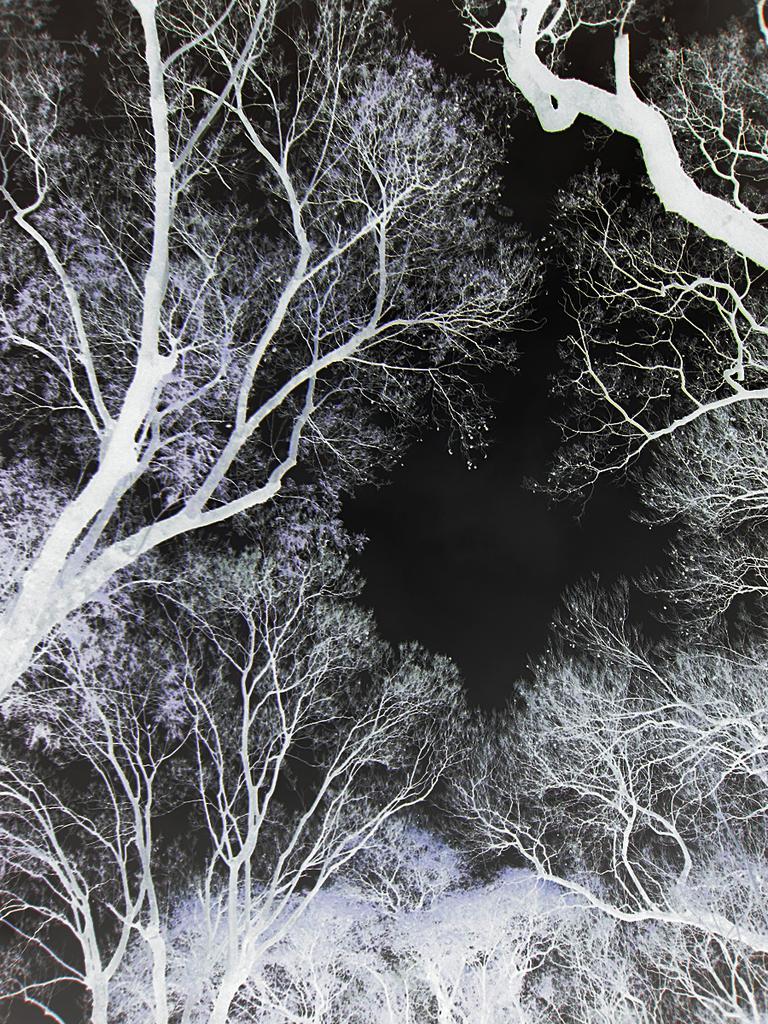In one or two sentences, can you explain what this image depicts? In this image I can see there are trees in the middle it is a sky in the night time, this image is in black and white color. 